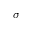<formula> <loc_0><loc_0><loc_500><loc_500>\sigma</formula> 